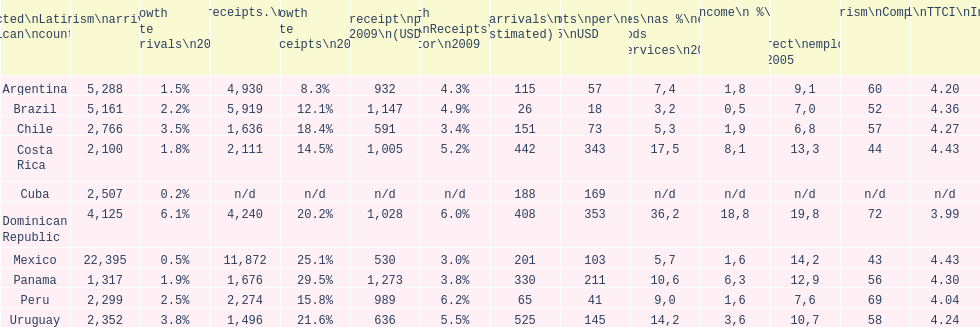How does brazil rank in average receipts per visitor in 2009? 1,147. 